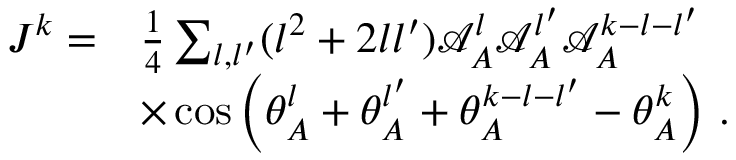Convert formula to latex. <formula><loc_0><loc_0><loc_500><loc_500>\begin{array} { r l } { J ^ { k } = } & { \frac { 1 } { 4 } \sum _ { { l } , { l ^ { \prime } } } ( { l } ^ { 2 } + 2 { l } { l ^ { \prime } } ) \mathcal { A } _ { A } ^ { l } \mathcal { A } _ { A } ^ { l ^ { \prime } } \mathcal { A } _ { A } ^ { k - { l } - { l ^ { \prime } } } } \\ & { \times \cos \left ( \theta _ { A } ^ { l } + \theta _ { A } ^ { l ^ { \prime } } + \theta _ { A } ^ { k - { l } - { l ^ { \prime } } } - \theta _ { A } ^ { k } \right ) \, . } \end{array}</formula> 